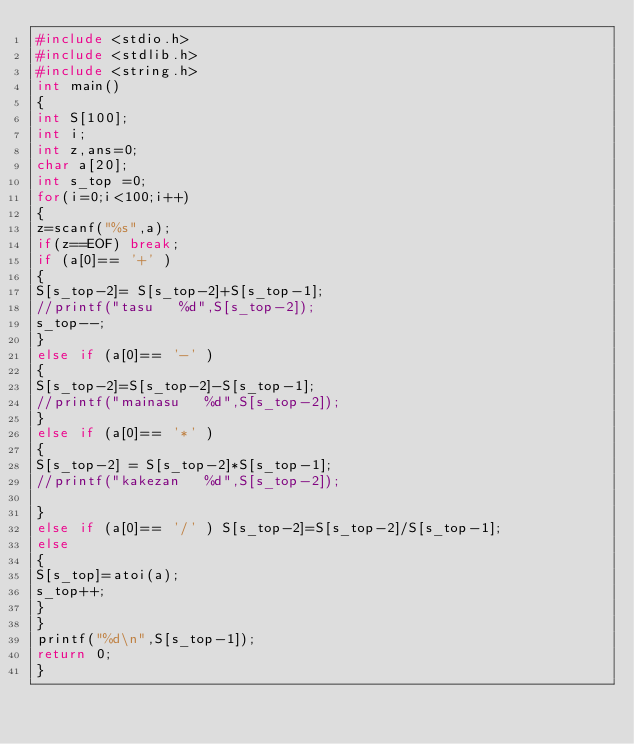Convert code to text. <code><loc_0><loc_0><loc_500><loc_500><_C_>#include <stdio.h>
#include <stdlib.h>
#include <string.h>
int main()
{
int S[100];
int i;
int z,ans=0;
char a[20];
int s_top =0;
for(i=0;i<100;i++)
{
z=scanf("%s",a);
if(z==EOF) break;
if (a[0]== '+' ) 
{
S[s_top-2]= S[s_top-2]+S[s_top-1];
//printf("tasu   %d",S[s_top-2]);
s_top--;
}
else if (a[0]== '-' )
{
S[s_top-2]=S[s_top-2]-S[s_top-1];
//printf("mainasu   %d",S[s_top-2]);
}
else if (a[0]== '*' ) 
{
S[s_top-2] = S[s_top-2]*S[s_top-1];
//printf("kakezan   %d",S[s_top-2]);

}
else if (a[0]== '/' ) S[s_top-2]=S[s_top-2]/S[s_top-1];
else 
{
S[s_top]=atoi(a);
s_top++;
}
}  
printf("%d\n",S[s_top-1]);
return 0;
}</code> 